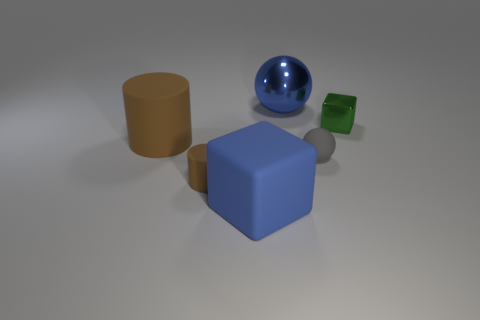Add 1 tiny things. How many objects exist? 7 Subtract all balls. How many objects are left? 4 Add 3 small brown things. How many small brown things are left? 4 Add 3 green matte balls. How many green matte balls exist? 3 Subtract 0 yellow blocks. How many objects are left? 6 Subtract all small blue metallic cylinders. Subtract all large blue shiny things. How many objects are left? 5 